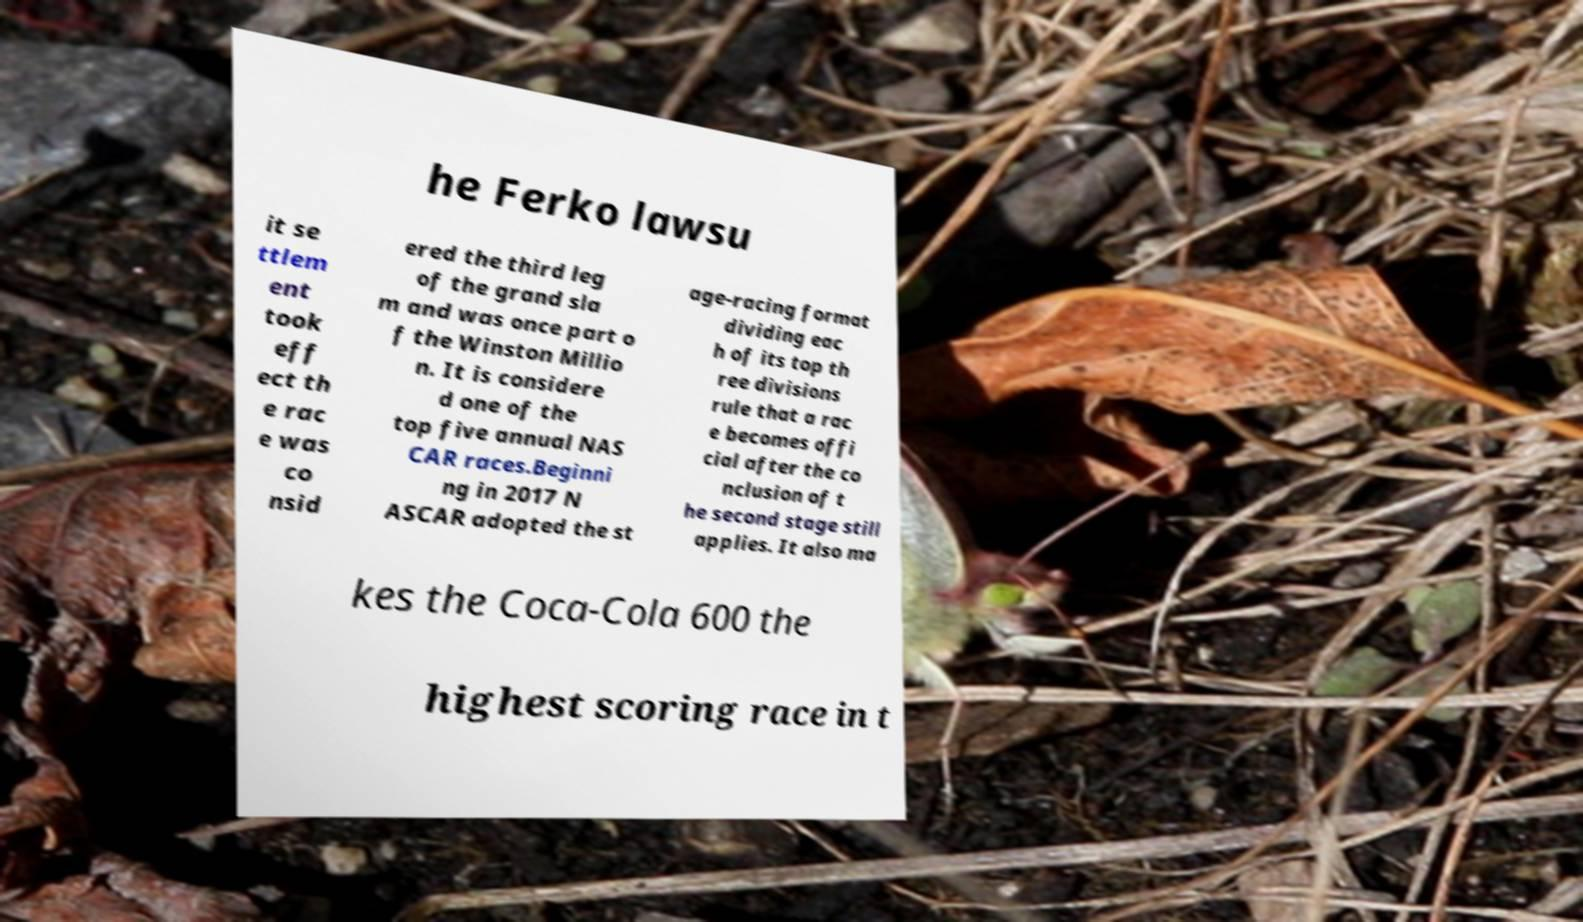For documentation purposes, I need the text within this image transcribed. Could you provide that? he Ferko lawsu it se ttlem ent took eff ect th e rac e was co nsid ered the third leg of the grand sla m and was once part o f the Winston Millio n. It is considere d one of the top five annual NAS CAR races.Beginni ng in 2017 N ASCAR adopted the st age-racing format dividing eac h of its top th ree divisions rule that a rac e becomes offi cial after the co nclusion of t he second stage still applies. It also ma kes the Coca-Cola 600 the highest scoring race in t 